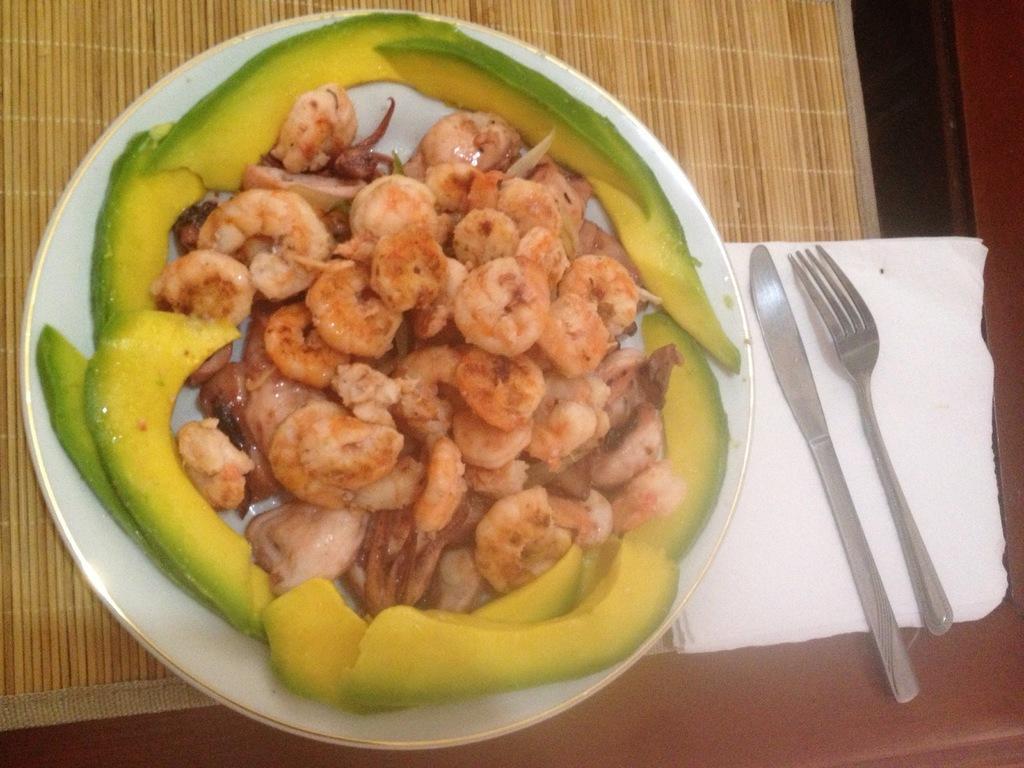Describe this image in one or two sentences. In this picture we can see a table, there is a plate, tissue papers, a knife and a fork present on the table, we can see some food present in the plate. 